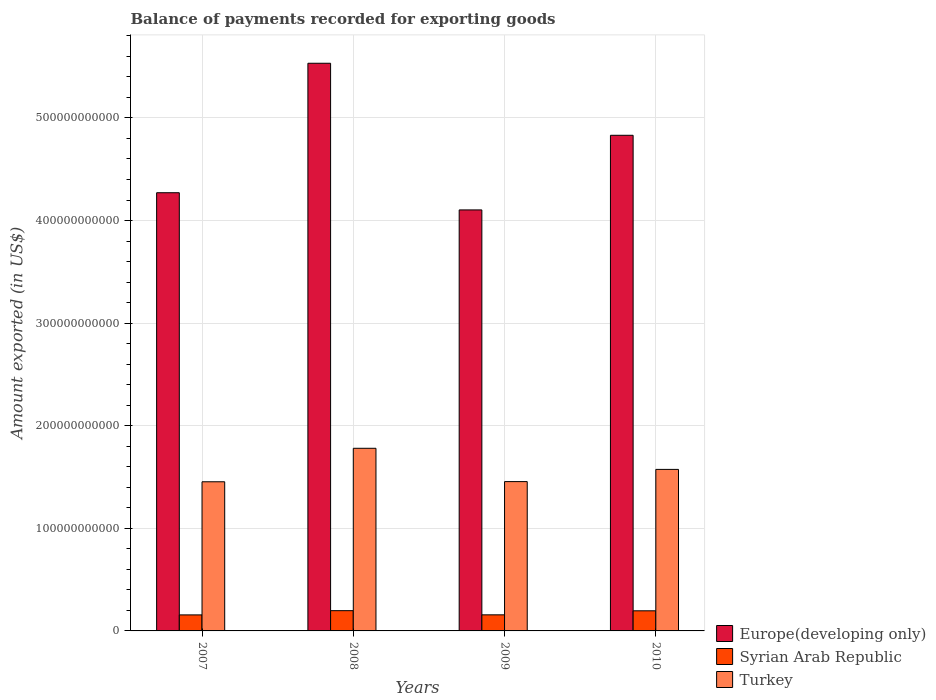How many groups of bars are there?
Ensure brevity in your answer.  4. Are the number of bars per tick equal to the number of legend labels?
Provide a succinct answer. Yes. Are the number of bars on each tick of the X-axis equal?
Provide a short and direct response. Yes. In how many cases, is the number of bars for a given year not equal to the number of legend labels?
Make the answer very short. 0. What is the amount exported in Turkey in 2009?
Offer a terse response. 1.46e+11. Across all years, what is the maximum amount exported in Syrian Arab Republic?
Offer a very short reply. 1.97e+1. Across all years, what is the minimum amount exported in Europe(developing only)?
Make the answer very short. 4.10e+11. In which year was the amount exported in Syrian Arab Republic minimum?
Make the answer very short. 2007. What is the total amount exported in Turkey in the graph?
Offer a very short reply. 6.26e+11. What is the difference between the amount exported in Turkey in 2008 and that in 2010?
Make the answer very short. 2.06e+1. What is the difference between the amount exported in Europe(developing only) in 2007 and the amount exported in Turkey in 2010?
Ensure brevity in your answer.  2.70e+11. What is the average amount exported in Europe(developing only) per year?
Give a very brief answer. 4.68e+11. In the year 2008, what is the difference between the amount exported in Europe(developing only) and amount exported in Turkey?
Keep it short and to the point. 3.75e+11. What is the ratio of the amount exported in Turkey in 2008 to that in 2010?
Make the answer very short. 1.13. Is the difference between the amount exported in Europe(developing only) in 2007 and 2010 greater than the difference between the amount exported in Turkey in 2007 and 2010?
Your response must be concise. No. What is the difference between the highest and the second highest amount exported in Syrian Arab Republic?
Offer a terse response. 1.44e+08. What is the difference between the highest and the lowest amount exported in Syrian Arab Republic?
Offer a very short reply. 4.13e+09. Is the sum of the amount exported in Syrian Arab Republic in 2007 and 2010 greater than the maximum amount exported in Europe(developing only) across all years?
Offer a very short reply. No. What does the 3rd bar from the left in 2008 represents?
Ensure brevity in your answer.  Turkey. What does the 3rd bar from the right in 2009 represents?
Your response must be concise. Europe(developing only). Are all the bars in the graph horizontal?
Give a very brief answer. No. What is the difference between two consecutive major ticks on the Y-axis?
Give a very brief answer. 1.00e+11. Are the values on the major ticks of Y-axis written in scientific E-notation?
Provide a succinct answer. No. Does the graph contain any zero values?
Provide a succinct answer. No. Does the graph contain grids?
Keep it short and to the point. Yes. How are the legend labels stacked?
Offer a terse response. Vertical. What is the title of the graph?
Offer a very short reply. Balance of payments recorded for exporting goods. Does "Bahamas" appear as one of the legend labels in the graph?
Your answer should be compact. No. What is the label or title of the X-axis?
Your answer should be compact. Years. What is the label or title of the Y-axis?
Ensure brevity in your answer.  Amount exported (in US$). What is the Amount exported (in US$) in Europe(developing only) in 2007?
Your answer should be very brief. 4.27e+11. What is the Amount exported (in US$) of Syrian Arab Republic in 2007?
Your answer should be compact. 1.56e+1. What is the Amount exported (in US$) in Turkey in 2007?
Provide a short and direct response. 1.45e+11. What is the Amount exported (in US$) of Europe(developing only) in 2008?
Offer a terse response. 5.53e+11. What is the Amount exported (in US$) in Syrian Arab Republic in 2008?
Your answer should be very brief. 1.97e+1. What is the Amount exported (in US$) of Turkey in 2008?
Ensure brevity in your answer.  1.78e+11. What is the Amount exported (in US$) in Europe(developing only) in 2009?
Keep it short and to the point. 4.10e+11. What is the Amount exported (in US$) of Syrian Arab Republic in 2009?
Keep it short and to the point. 1.57e+1. What is the Amount exported (in US$) in Turkey in 2009?
Your answer should be very brief. 1.46e+11. What is the Amount exported (in US$) of Europe(developing only) in 2010?
Ensure brevity in your answer.  4.83e+11. What is the Amount exported (in US$) of Syrian Arab Republic in 2010?
Give a very brief answer. 1.96e+1. What is the Amount exported (in US$) in Turkey in 2010?
Ensure brevity in your answer.  1.57e+11. Across all years, what is the maximum Amount exported (in US$) in Europe(developing only)?
Provide a short and direct response. 5.53e+11. Across all years, what is the maximum Amount exported (in US$) in Syrian Arab Republic?
Your answer should be compact. 1.97e+1. Across all years, what is the maximum Amount exported (in US$) of Turkey?
Make the answer very short. 1.78e+11. Across all years, what is the minimum Amount exported (in US$) of Europe(developing only)?
Your answer should be very brief. 4.10e+11. Across all years, what is the minimum Amount exported (in US$) of Syrian Arab Republic?
Provide a short and direct response. 1.56e+1. Across all years, what is the minimum Amount exported (in US$) in Turkey?
Make the answer very short. 1.45e+11. What is the total Amount exported (in US$) in Europe(developing only) in the graph?
Offer a terse response. 1.87e+12. What is the total Amount exported (in US$) of Syrian Arab Republic in the graph?
Your response must be concise. 7.07e+1. What is the total Amount exported (in US$) of Turkey in the graph?
Your answer should be very brief. 6.26e+11. What is the difference between the Amount exported (in US$) in Europe(developing only) in 2007 and that in 2008?
Keep it short and to the point. -1.26e+11. What is the difference between the Amount exported (in US$) in Syrian Arab Republic in 2007 and that in 2008?
Offer a very short reply. -4.13e+09. What is the difference between the Amount exported (in US$) in Turkey in 2007 and that in 2008?
Your answer should be compact. -3.26e+1. What is the difference between the Amount exported (in US$) in Europe(developing only) in 2007 and that in 2009?
Your answer should be very brief. 1.67e+1. What is the difference between the Amount exported (in US$) in Syrian Arab Republic in 2007 and that in 2009?
Offer a very short reply. -6.49e+07. What is the difference between the Amount exported (in US$) in Turkey in 2007 and that in 2009?
Give a very brief answer. -1.64e+08. What is the difference between the Amount exported (in US$) of Europe(developing only) in 2007 and that in 2010?
Give a very brief answer. -5.60e+1. What is the difference between the Amount exported (in US$) in Syrian Arab Republic in 2007 and that in 2010?
Offer a very short reply. -3.99e+09. What is the difference between the Amount exported (in US$) in Turkey in 2007 and that in 2010?
Make the answer very short. -1.21e+1. What is the difference between the Amount exported (in US$) in Europe(developing only) in 2008 and that in 2009?
Your answer should be very brief. 1.43e+11. What is the difference between the Amount exported (in US$) in Syrian Arab Republic in 2008 and that in 2009?
Offer a terse response. 4.07e+09. What is the difference between the Amount exported (in US$) in Turkey in 2008 and that in 2009?
Your response must be concise. 3.25e+1. What is the difference between the Amount exported (in US$) in Europe(developing only) in 2008 and that in 2010?
Your answer should be compact. 7.02e+1. What is the difference between the Amount exported (in US$) in Syrian Arab Republic in 2008 and that in 2010?
Keep it short and to the point. 1.44e+08. What is the difference between the Amount exported (in US$) in Turkey in 2008 and that in 2010?
Provide a short and direct response. 2.06e+1. What is the difference between the Amount exported (in US$) of Europe(developing only) in 2009 and that in 2010?
Your answer should be very brief. -7.27e+1. What is the difference between the Amount exported (in US$) in Syrian Arab Republic in 2009 and that in 2010?
Make the answer very short. -3.92e+09. What is the difference between the Amount exported (in US$) in Turkey in 2009 and that in 2010?
Make the answer very short. -1.19e+1. What is the difference between the Amount exported (in US$) of Europe(developing only) in 2007 and the Amount exported (in US$) of Syrian Arab Republic in 2008?
Ensure brevity in your answer.  4.07e+11. What is the difference between the Amount exported (in US$) of Europe(developing only) in 2007 and the Amount exported (in US$) of Turkey in 2008?
Your answer should be very brief. 2.49e+11. What is the difference between the Amount exported (in US$) of Syrian Arab Republic in 2007 and the Amount exported (in US$) of Turkey in 2008?
Provide a short and direct response. -1.62e+11. What is the difference between the Amount exported (in US$) in Europe(developing only) in 2007 and the Amount exported (in US$) in Syrian Arab Republic in 2009?
Offer a terse response. 4.11e+11. What is the difference between the Amount exported (in US$) of Europe(developing only) in 2007 and the Amount exported (in US$) of Turkey in 2009?
Make the answer very short. 2.82e+11. What is the difference between the Amount exported (in US$) in Syrian Arab Republic in 2007 and the Amount exported (in US$) in Turkey in 2009?
Provide a short and direct response. -1.30e+11. What is the difference between the Amount exported (in US$) of Europe(developing only) in 2007 and the Amount exported (in US$) of Syrian Arab Republic in 2010?
Your answer should be very brief. 4.08e+11. What is the difference between the Amount exported (in US$) in Europe(developing only) in 2007 and the Amount exported (in US$) in Turkey in 2010?
Make the answer very short. 2.70e+11. What is the difference between the Amount exported (in US$) in Syrian Arab Republic in 2007 and the Amount exported (in US$) in Turkey in 2010?
Provide a short and direct response. -1.42e+11. What is the difference between the Amount exported (in US$) in Europe(developing only) in 2008 and the Amount exported (in US$) in Syrian Arab Republic in 2009?
Make the answer very short. 5.38e+11. What is the difference between the Amount exported (in US$) in Europe(developing only) in 2008 and the Amount exported (in US$) in Turkey in 2009?
Your response must be concise. 4.08e+11. What is the difference between the Amount exported (in US$) in Syrian Arab Republic in 2008 and the Amount exported (in US$) in Turkey in 2009?
Your answer should be compact. -1.26e+11. What is the difference between the Amount exported (in US$) in Europe(developing only) in 2008 and the Amount exported (in US$) in Syrian Arab Republic in 2010?
Provide a succinct answer. 5.34e+11. What is the difference between the Amount exported (in US$) of Europe(developing only) in 2008 and the Amount exported (in US$) of Turkey in 2010?
Make the answer very short. 3.96e+11. What is the difference between the Amount exported (in US$) of Syrian Arab Republic in 2008 and the Amount exported (in US$) of Turkey in 2010?
Ensure brevity in your answer.  -1.38e+11. What is the difference between the Amount exported (in US$) of Europe(developing only) in 2009 and the Amount exported (in US$) of Syrian Arab Republic in 2010?
Give a very brief answer. 3.91e+11. What is the difference between the Amount exported (in US$) of Europe(developing only) in 2009 and the Amount exported (in US$) of Turkey in 2010?
Offer a terse response. 2.53e+11. What is the difference between the Amount exported (in US$) of Syrian Arab Republic in 2009 and the Amount exported (in US$) of Turkey in 2010?
Provide a succinct answer. -1.42e+11. What is the average Amount exported (in US$) in Europe(developing only) per year?
Keep it short and to the point. 4.68e+11. What is the average Amount exported (in US$) in Syrian Arab Republic per year?
Make the answer very short. 1.77e+1. What is the average Amount exported (in US$) of Turkey per year?
Offer a terse response. 1.57e+11. In the year 2007, what is the difference between the Amount exported (in US$) of Europe(developing only) and Amount exported (in US$) of Syrian Arab Republic?
Give a very brief answer. 4.11e+11. In the year 2007, what is the difference between the Amount exported (in US$) in Europe(developing only) and Amount exported (in US$) in Turkey?
Provide a short and direct response. 2.82e+11. In the year 2007, what is the difference between the Amount exported (in US$) in Syrian Arab Republic and Amount exported (in US$) in Turkey?
Your response must be concise. -1.30e+11. In the year 2008, what is the difference between the Amount exported (in US$) in Europe(developing only) and Amount exported (in US$) in Syrian Arab Republic?
Keep it short and to the point. 5.34e+11. In the year 2008, what is the difference between the Amount exported (in US$) in Europe(developing only) and Amount exported (in US$) in Turkey?
Your answer should be very brief. 3.75e+11. In the year 2008, what is the difference between the Amount exported (in US$) of Syrian Arab Republic and Amount exported (in US$) of Turkey?
Your response must be concise. -1.58e+11. In the year 2009, what is the difference between the Amount exported (in US$) in Europe(developing only) and Amount exported (in US$) in Syrian Arab Republic?
Your response must be concise. 3.95e+11. In the year 2009, what is the difference between the Amount exported (in US$) in Europe(developing only) and Amount exported (in US$) in Turkey?
Keep it short and to the point. 2.65e+11. In the year 2009, what is the difference between the Amount exported (in US$) in Syrian Arab Republic and Amount exported (in US$) in Turkey?
Offer a terse response. -1.30e+11. In the year 2010, what is the difference between the Amount exported (in US$) of Europe(developing only) and Amount exported (in US$) of Syrian Arab Republic?
Your answer should be compact. 4.63e+11. In the year 2010, what is the difference between the Amount exported (in US$) of Europe(developing only) and Amount exported (in US$) of Turkey?
Provide a succinct answer. 3.26e+11. In the year 2010, what is the difference between the Amount exported (in US$) in Syrian Arab Republic and Amount exported (in US$) in Turkey?
Your answer should be compact. -1.38e+11. What is the ratio of the Amount exported (in US$) of Europe(developing only) in 2007 to that in 2008?
Ensure brevity in your answer.  0.77. What is the ratio of the Amount exported (in US$) of Syrian Arab Republic in 2007 to that in 2008?
Keep it short and to the point. 0.79. What is the ratio of the Amount exported (in US$) of Turkey in 2007 to that in 2008?
Keep it short and to the point. 0.82. What is the ratio of the Amount exported (in US$) of Europe(developing only) in 2007 to that in 2009?
Your response must be concise. 1.04. What is the ratio of the Amount exported (in US$) of Syrian Arab Republic in 2007 to that in 2009?
Your answer should be very brief. 1. What is the ratio of the Amount exported (in US$) in Europe(developing only) in 2007 to that in 2010?
Provide a succinct answer. 0.88. What is the ratio of the Amount exported (in US$) in Syrian Arab Republic in 2007 to that in 2010?
Provide a short and direct response. 0.8. What is the ratio of the Amount exported (in US$) of Turkey in 2007 to that in 2010?
Give a very brief answer. 0.92. What is the ratio of the Amount exported (in US$) in Europe(developing only) in 2008 to that in 2009?
Your answer should be compact. 1.35. What is the ratio of the Amount exported (in US$) in Syrian Arab Republic in 2008 to that in 2009?
Make the answer very short. 1.26. What is the ratio of the Amount exported (in US$) of Turkey in 2008 to that in 2009?
Your answer should be very brief. 1.22. What is the ratio of the Amount exported (in US$) of Europe(developing only) in 2008 to that in 2010?
Your answer should be very brief. 1.15. What is the ratio of the Amount exported (in US$) of Syrian Arab Republic in 2008 to that in 2010?
Offer a very short reply. 1.01. What is the ratio of the Amount exported (in US$) of Turkey in 2008 to that in 2010?
Ensure brevity in your answer.  1.13. What is the ratio of the Amount exported (in US$) in Europe(developing only) in 2009 to that in 2010?
Keep it short and to the point. 0.85. What is the ratio of the Amount exported (in US$) of Syrian Arab Republic in 2009 to that in 2010?
Give a very brief answer. 0.8. What is the ratio of the Amount exported (in US$) in Turkey in 2009 to that in 2010?
Ensure brevity in your answer.  0.92. What is the difference between the highest and the second highest Amount exported (in US$) of Europe(developing only)?
Offer a terse response. 7.02e+1. What is the difference between the highest and the second highest Amount exported (in US$) in Syrian Arab Republic?
Provide a short and direct response. 1.44e+08. What is the difference between the highest and the second highest Amount exported (in US$) of Turkey?
Give a very brief answer. 2.06e+1. What is the difference between the highest and the lowest Amount exported (in US$) in Europe(developing only)?
Provide a succinct answer. 1.43e+11. What is the difference between the highest and the lowest Amount exported (in US$) in Syrian Arab Republic?
Provide a short and direct response. 4.13e+09. What is the difference between the highest and the lowest Amount exported (in US$) of Turkey?
Your answer should be very brief. 3.26e+1. 